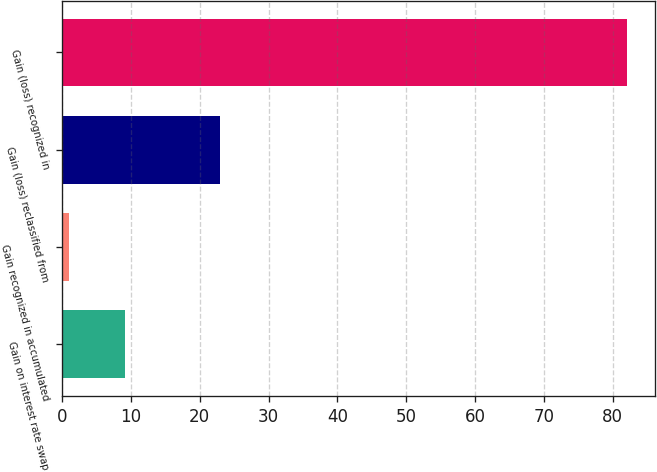Convert chart. <chart><loc_0><loc_0><loc_500><loc_500><bar_chart><fcel>Gain on interest rate swap<fcel>Gain recognized in accumulated<fcel>Gain (loss) reclassified from<fcel>Gain (loss) recognized in<nl><fcel>9.1<fcel>1<fcel>23<fcel>82<nl></chart> 